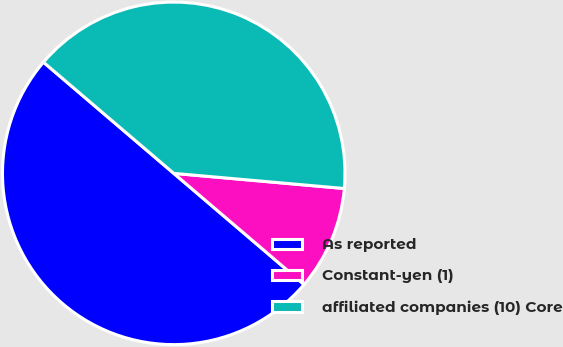<chart> <loc_0><loc_0><loc_500><loc_500><pie_chart><fcel>As reported<fcel>Constant-yen (1)<fcel>affiliated companies (10) Core<nl><fcel>50.0%<fcel>9.83%<fcel>40.17%<nl></chart> 